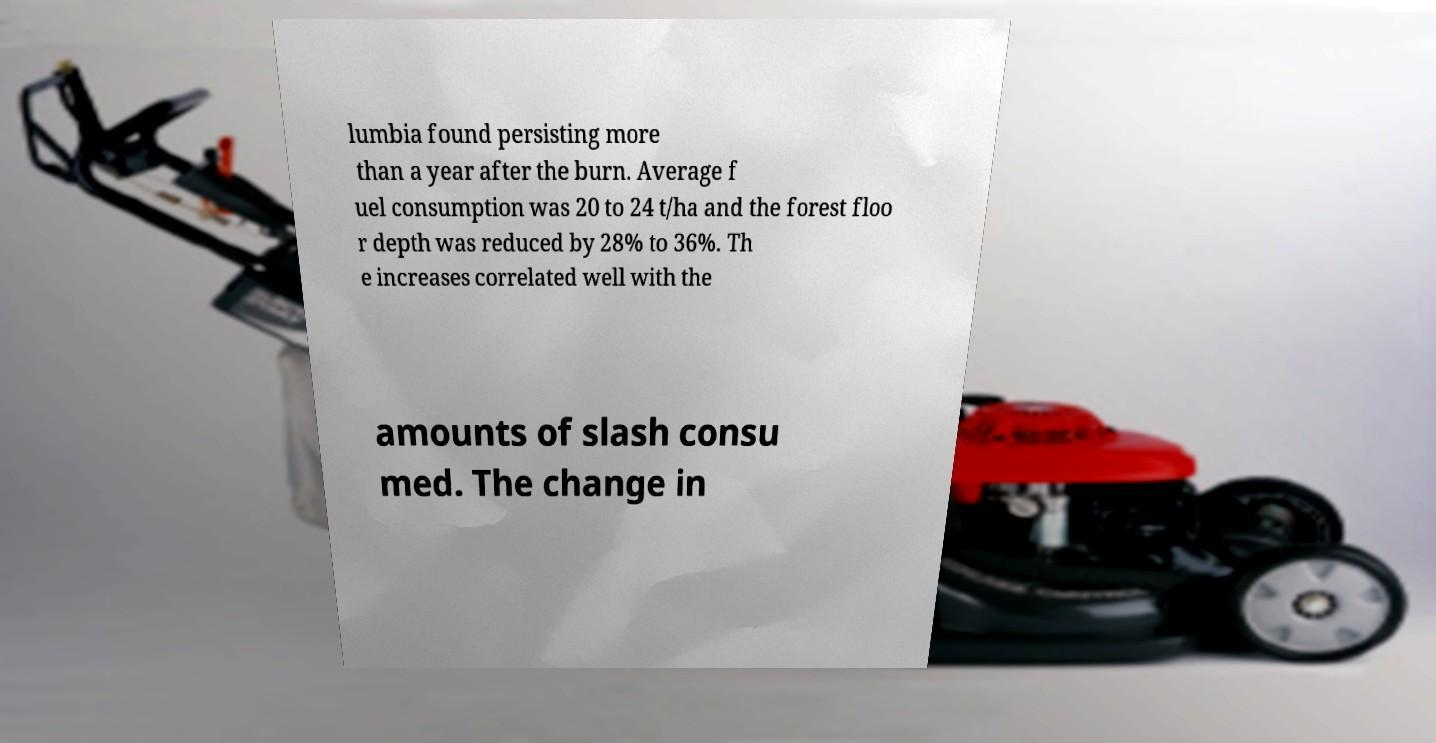Please identify and transcribe the text found in this image. lumbia found persisting more than a year after the burn. Average f uel consumption was 20 to 24 t/ha and the forest floo r depth was reduced by 28% to 36%. Th e increases correlated well with the amounts of slash consu med. The change in 